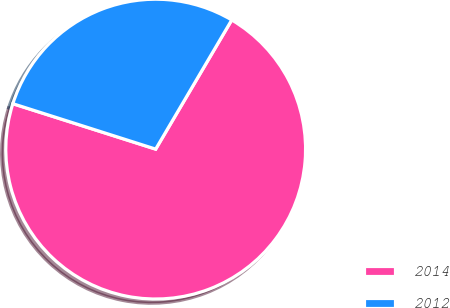Convert chart. <chart><loc_0><loc_0><loc_500><loc_500><pie_chart><fcel>2014<fcel>2012<nl><fcel>71.43%<fcel>28.57%<nl></chart> 